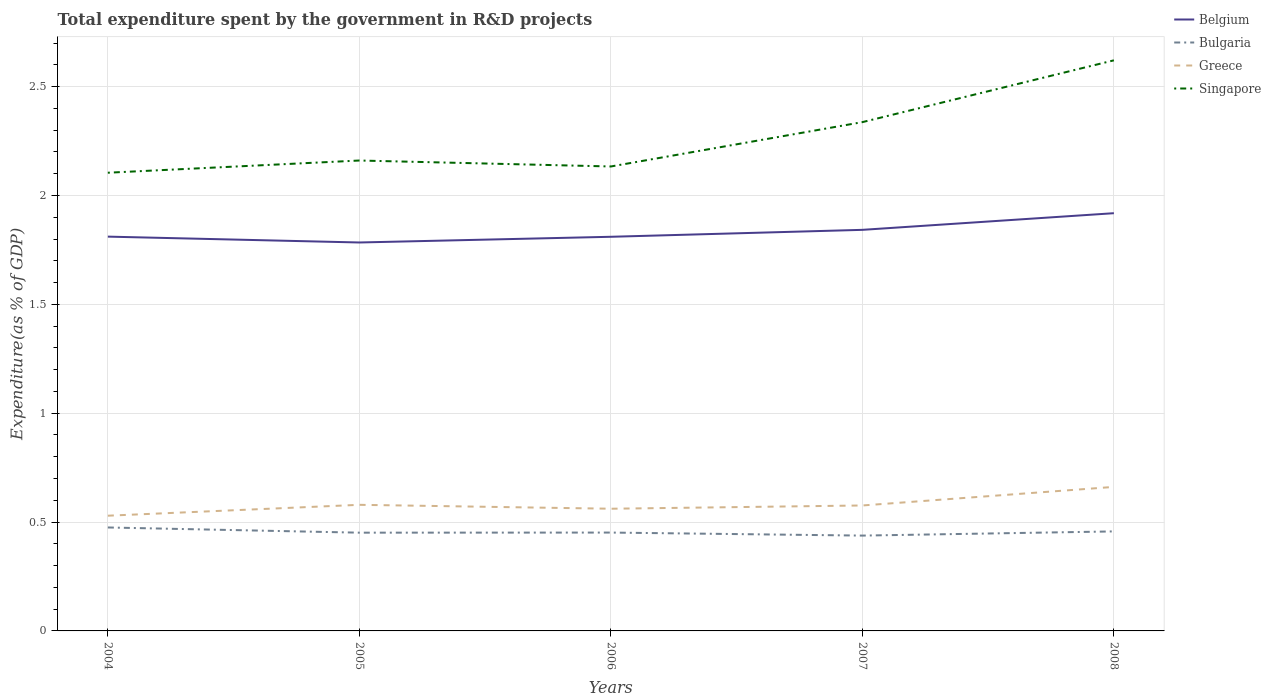Across all years, what is the maximum total expenditure spent by the government in R&D projects in Belgium?
Your answer should be compact. 1.78. What is the total total expenditure spent by the government in R&D projects in Greece in the graph?
Provide a succinct answer. 0. What is the difference between the highest and the second highest total expenditure spent by the government in R&D projects in Greece?
Your answer should be compact. 0.13. What is the difference between the highest and the lowest total expenditure spent by the government in R&D projects in Bulgaria?
Provide a succinct answer. 2. How many years are there in the graph?
Provide a short and direct response. 5. Are the values on the major ticks of Y-axis written in scientific E-notation?
Your answer should be compact. No. How many legend labels are there?
Keep it short and to the point. 4. What is the title of the graph?
Make the answer very short. Total expenditure spent by the government in R&D projects. Does "Romania" appear as one of the legend labels in the graph?
Make the answer very short. No. What is the label or title of the Y-axis?
Make the answer very short. Expenditure(as % of GDP). What is the Expenditure(as % of GDP) of Belgium in 2004?
Provide a succinct answer. 1.81. What is the Expenditure(as % of GDP) in Bulgaria in 2004?
Make the answer very short. 0.48. What is the Expenditure(as % of GDP) in Greece in 2004?
Give a very brief answer. 0.53. What is the Expenditure(as % of GDP) of Singapore in 2004?
Your answer should be compact. 2.1. What is the Expenditure(as % of GDP) in Belgium in 2005?
Keep it short and to the point. 1.78. What is the Expenditure(as % of GDP) in Bulgaria in 2005?
Provide a succinct answer. 0.45. What is the Expenditure(as % of GDP) of Greece in 2005?
Give a very brief answer. 0.58. What is the Expenditure(as % of GDP) in Singapore in 2005?
Keep it short and to the point. 2.16. What is the Expenditure(as % of GDP) in Belgium in 2006?
Keep it short and to the point. 1.81. What is the Expenditure(as % of GDP) of Bulgaria in 2006?
Provide a succinct answer. 0.45. What is the Expenditure(as % of GDP) in Greece in 2006?
Ensure brevity in your answer.  0.56. What is the Expenditure(as % of GDP) of Singapore in 2006?
Make the answer very short. 2.13. What is the Expenditure(as % of GDP) of Belgium in 2007?
Ensure brevity in your answer.  1.84. What is the Expenditure(as % of GDP) of Bulgaria in 2007?
Provide a short and direct response. 0.44. What is the Expenditure(as % of GDP) in Greece in 2007?
Your answer should be compact. 0.58. What is the Expenditure(as % of GDP) of Singapore in 2007?
Your answer should be compact. 2.34. What is the Expenditure(as % of GDP) in Belgium in 2008?
Your response must be concise. 1.92. What is the Expenditure(as % of GDP) of Bulgaria in 2008?
Offer a terse response. 0.46. What is the Expenditure(as % of GDP) in Greece in 2008?
Your answer should be compact. 0.66. What is the Expenditure(as % of GDP) in Singapore in 2008?
Offer a terse response. 2.62. Across all years, what is the maximum Expenditure(as % of GDP) of Belgium?
Give a very brief answer. 1.92. Across all years, what is the maximum Expenditure(as % of GDP) of Bulgaria?
Offer a very short reply. 0.48. Across all years, what is the maximum Expenditure(as % of GDP) of Greece?
Give a very brief answer. 0.66. Across all years, what is the maximum Expenditure(as % of GDP) of Singapore?
Your answer should be compact. 2.62. Across all years, what is the minimum Expenditure(as % of GDP) in Belgium?
Your answer should be compact. 1.78. Across all years, what is the minimum Expenditure(as % of GDP) in Bulgaria?
Give a very brief answer. 0.44. Across all years, what is the minimum Expenditure(as % of GDP) of Greece?
Offer a very short reply. 0.53. Across all years, what is the minimum Expenditure(as % of GDP) of Singapore?
Keep it short and to the point. 2.1. What is the total Expenditure(as % of GDP) in Belgium in the graph?
Your answer should be very brief. 9.17. What is the total Expenditure(as % of GDP) of Bulgaria in the graph?
Your answer should be compact. 2.27. What is the total Expenditure(as % of GDP) of Greece in the graph?
Offer a very short reply. 2.91. What is the total Expenditure(as % of GDP) in Singapore in the graph?
Provide a succinct answer. 11.36. What is the difference between the Expenditure(as % of GDP) of Belgium in 2004 and that in 2005?
Your answer should be very brief. 0.03. What is the difference between the Expenditure(as % of GDP) in Bulgaria in 2004 and that in 2005?
Your response must be concise. 0.02. What is the difference between the Expenditure(as % of GDP) of Greece in 2004 and that in 2005?
Give a very brief answer. -0.05. What is the difference between the Expenditure(as % of GDP) in Singapore in 2004 and that in 2005?
Keep it short and to the point. -0.06. What is the difference between the Expenditure(as % of GDP) in Belgium in 2004 and that in 2006?
Make the answer very short. 0. What is the difference between the Expenditure(as % of GDP) in Bulgaria in 2004 and that in 2006?
Your answer should be very brief. 0.02. What is the difference between the Expenditure(as % of GDP) of Greece in 2004 and that in 2006?
Ensure brevity in your answer.  -0.03. What is the difference between the Expenditure(as % of GDP) of Singapore in 2004 and that in 2006?
Make the answer very short. -0.03. What is the difference between the Expenditure(as % of GDP) in Belgium in 2004 and that in 2007?
Keep it short and to the point. -0.03. What is the difference between the Expenditure(as % of GDP) in Bulgaria in 2004 and that in 2007?
Provide a succinct answer. 0.04. What is the difference between the Expenditure(as % of GDP) of Greece in 2004 and that in 2007?
Your response must be concise. -0.05. What is the difference between the Expenditure(as % of GDP) in Singapore in 2004 and that in 2007?
Provide a succinct answer. -0.23. What is the difference between the Expenditure(as % of GDP) in Belgium in 2004 and that in 2008?
Make the answer very short. -0.11. What is the difference between the Expenditure(as % of GDP) of Bulgaria in 2004 and that in 2008?
Give a very brief answer. 0.02. What is the difference between the Expenditure(as % of GDP) in Greece in 2004 and that in 2008?
Your answer should be very brief. -0.13. What is the difference between the Expenditure(as % of GDP) of Singapore in 2004 and that in 2008?
Keep it short and to the point. -0.52. What is the difference between the Expenditure(as % of GDP) of Belgium in 2005 and that in 2006?
Make the answer very short. -0.03. What is the difference between the Expenditure(as % of GDP) in Bulgaria in 2005 and that in 2006?
Make the answer very short. -0. What is the difference between the Expenditure(as % of GDP) of Greece in 2005 and that in 2006?
Your answer should be very brief. 0.02. What is the difference between the Expenditure(as % of GDP) in Singapore in 2005 and that in 2006?
Give a very brief answer. 0.03. What is the difference between the Expenditure(as % of GDP) of Belgium in 2005 and that in 2007?
Your answer should be compact. -0.06. What is the difference between the Expenditure(as % of GDP) in Bulgaria in 2005 and that in 2007?
Your answer should be very brief. 0.01. What is the difference between the Expenditure(as % of GDP) of Greece in 2005 and that in 2007?
Offer a very short reply. 0. What is the difference between the Expenditure(as % of GDP) in Singapore in 2005 and that in 2007?
Your answer should be very brief. -0.18. What is the difference between the Expenditure(as % of GDP) in Belgium in 2005 and that in 2008?
Provide a succinct answer. -0.13. What is the difference between the Expenditure(as % of GDP) in Bulgaria in 2005 and that in 2008?
Offer a terse response. -0.01. What is the difference between the Expenditure(as % of GDP) of Greece in 2005 and that in 2008?
Provide a short and direct response. -0.08. What is the difference between the Expenditure(as % of GDP) in Singapore in 2005 and that in 2008?
Offer a terse response. -0.46. What is the difference between the Expenditure(as % of GDP) in Belgium in 2006 and that in 2007?
Your answer should be very brief. -0.03. What is the difference between the Expenditure(as % of GDP) in Bulgaria in 2006 and that in 2007?
Offer a very short reply. 0.01. What is the difference between the Expenditure(as % of GDP) of Greece in 2006 and that in 2007?
Keep it short and to the point. -0.01. What is the difference between the Expenditure(as % of GDP) in Singapore in 2006 and that in 2007?
Keep it short and to the point. -0.2. What is the difference between the Expenditure(as % of GDP) of Belgium in 2006 and that in 2008?
Keep it short and to the point. -0.11. What is the difference between the Expenditure(as % of GDP) of Bulgaria in 2006 and that in 2008?
Your answer should be compact. -0.01. What is the difference between the Expenditure(as % of GDP) in Greece in 2006 and that in 2008?
Provide a short and direct response. -0.1. What is the difference between the Expenditure(as % of GDP) in Singapore in 2006 and that in 2008?
Offer a terse response. -0.49. What is the difference between the Expenditure(as % of GDP) of Belgium in 2007 and that in 2008?
Your response must be concise. -0.08. What is the difference between the Expenditure(as % of GDP) of Bulgaria in 2007 and that in 2008?
Provide a short and direct response. -0.02. What is the difference between the Expenditure(as % of GDP) in Greece in 2007 and that in 2008?
Make the answer very short. -0.09. What is the difference between the Expenditure(as % of GDP) of Singapore in 2007 and that in 2008?
Your answer should be very brief. -0.28. What is the difference between the Expenditure(as % of GDP) of Belgium in 2004 and the Expenditure(as % of GDP) of Bulgaria in 2005?
Give a very brief answer. 1.36. What is the difference between the Expenditure(as % of GDP) of Belgium in 2004 and the Expenditure(as % of GDP) of Greece in 2005?
Make the answer very short. 1.23. What is the difference between the Expenditure(as % of GDP) of Belgium in 2004 and the Expenditure(as % of GDP) of Singapore in 2005?
Your answer should be compact. -0.35. What is the difference between the Expenditure(as % of GDP) in Bulgaria in 2004 and the Expenditure(as % of GDP) in Greece in 2005?
Offer a very short reply. -0.1. What is the difference between the Expenditure(as % of GDP) in Bulgaria in 2004 and the Expenditure(as % of GDP) in Singapore in 2005?
Your answer should be very brief. -1.69. What is the difference between the Expenditure(as % of GDP) in Greece in 2004 and the Expenditure(as % of GDP) in Singapore in 2005?
Ensure brevity in your answer.  -1.63. What is the difference between the Expenditure(as % of GDP) in Belgium in 2004 and the Expenditure(as % of GDP) in Bulgaria in 2006?
Your response must be concise. 1.36. What is the difference between the Expenditure(as % of GDP) in Belgium in 2004 and the Expenditure(as % of GDP) in Greece in 2006?
Your answer should be very brief. 1.25. What is the difference between the Expenditure(as % of GDP) in Belgium in 2004 and the Expenditure(as % of GDP) in Singapore in 2006?
Make the answer very short. -0.32. What is the difference between the Expenditure(as % of GDP) in Bulgaria in 2004 and the Expenditure(as % of GDP) in Greece in 2006?
Provide a succinct answer. -0.09. What is the difference between the Expenditure(as % of GDP) of Bulgaria in 2004 and the Expenditure(as % of GDP) of Singapore in 2006?
Offer a very short reply. -1.66. What is the difference between the Expenditure(as % of GDP) in Greece in 2004 and the Expenditure(as % of GDP) in Singapore in 2006?
Ensure brevity in your answer.  -1.6. What is the difference between the Expenditure(as % of GDP) in Belgium in 2004 and the Expenditure(as % of GDP) in Bulgaria in 2007?
Offer a terse response. 1.37. What is the difference between the Expenditure(as % of GDP) of Belgium in 2004 and the Expenditure(as % of GDP) of Greece in 2007?
Give a very brief answer. 1.23. What is the difference between the Expenditure(as % of GDP) in Belgium in 2004 and the Expenditure(as % of GDP) in Singapore in 2007?
Keep it short and to the point. -0.53. What is the difference between the Expenditure(as % of GDP) in Bulgaria in 2004 and the Expenditure(as % of GDP) in Greece in 2007?
Offer a very short reply. -0.1. What is the difference between the Expenditure(as % of GDP) in Bulgaria in 2004 and the Expenditure(as % of GDP) in Singapore in 2007?
Offer a terse response. -1.86. What is the difference between the Expenditure(as % of GDP) in Greece in 2004 and the Expenditure(as % of GDP) in Singapore in 2007?
Offer a terse response. -1.81. What is the difference between the Expenditure(as % of GDP) in Belgium in 2004 and the Expenditure(as % of GDP) in Bulgaria in 2008?
Offer a very short reply. 1.35. What is the difference between the Expenditure(as % of GDP) in Belgium in 2004 and the Expenditure(as % of GDP) in Greece in 2008?
Provide a short and direct response. 1.15. What is the difference between the Expenditure(as % of GDP) in Belgium in 2004 and the Expenditure(as % of GDP) in Singapore in 2008?
Provide a short and direct response. -0.81. What is the difference between the Expenditure(as % of GDP) in Bulgaria in 2004 and the Expenditure(as % of GDP) in Greece in 2008?
Offer a terse response. -0.19. What is the difference between the Expenditure(as % of GDP) in Bulgaria in 2004 and the Expenditure(as % of GDP) in Singapore in 2008?
Your answer should be very brief. -2.15. What is the difference between the Expenditure(as % of GDP) in Greece in 2004 and the Expenditure(as % of GDP) in Singapore in 2008?
Your answer should be compact. -2.09. What is the difference between the Expenditure(as % of GDP) of Belgium in 2005 and the Expenditure(as % of GDP) of Bulgaria in 2006?
Give a very brief answer. 1.33. What is the difference between the Expenditure(as % of GDP) of Belgium in 2005 and the Expenditure(as % of GDP) of Greece in 2006?
Your answer should be very brief. 1.22. What is the difference between the Expenditure(as % of GDP) in Belgium in 2005 and the Expenditure(as % of GDP) in Singapore in 2006?
Keep it short and to the point. -0.35. What is the difference between the Expenditure(as % of GDP) in Bulgaria in 2005 and the Expenditure(as % of GDP) in Greece in 2006?
Provide a short and direct response. -0.11. What is the difference between the Expenditure(as % of GDP) of Bulgaria in 2005 and the Expenditure(as % of GDP) of Singapore in 2006?
Your answer should be compact. -1.68. What is the difference between the Expenditure(as % of GDP) of Greece in 2005 and the Expenditure(as % of GDP) of Singapore in 2006?
Your answer should be very brief. -1.55. What is the difference between the Expenditure(as % of GDP) in Belgium in 2005 and the Expenditure(as % of GDP) in Bulgaria in 2007?
Offer a terse response. 1.35. What is the difference between the Expenditure(as % of GDP) in Belgium in 2005 and the Expenditure(as % of GDP) in Greece in 2007?
Offer a terse response. 1.21. What is the difference between the Expenditure(as % of GDP) in Belgium in 2005 and the Expenditure(as % of GDP) in Singapore in 2007?
Ensure brevity in your answer.  -0.55. What is the difference between the Expenditure(as % of GDP) in Bulgaria in 2005 and the Expenditure(as % of GDP) in Greece in 2007?
Your answer should be compact. -0.12. What is the difference between the Expenditure(as % of GDP) of Bulgaria in 2005 and the Expenditure(as % of GDP) of Singapore in 2007?
Keep it short and to the point. -1.89. What is the difference between the Expenditure(as % of GDP) in Greece in 2005 and the Expenditure(as % of GDP) in Singapore in 2007?
Make the answer very short. -1.76. What is the difference between the Expenditure(as % of GDP) of Belgium in 2005 and the Expenditure(as % of GDP) of Bulgaria in 2008?
Your answer should be compact. 1.33. What is the difference between the Expenditure(as % of GDP) of Belgium in 2005 and the Expenditure(as % of GDP) of Greece in 2008?
Your answer should be very brief. 1.12. What is the difference between the Expenditure(as % of GDP) in Belgium in 2005 and the Expenditure(as % of GDP) in Singapore in 2008?
Offer a terse response. -0.84. What is the difference between the Expenditure(as % of GDP) in Bulgaria in 2005 and the Expenditure(as % of GDP) in Greece in 2008?
Make the answer very short. -0.21. What is the difference between the Expenditure(as % of GDP) in Bulgaria in 2005 and the Expenditure(as % of GDP) in Singapore in 2008?
Your answer should be very brief. -2.17. What is the difference between the Expenditure(as % of GDP) in Greece in 2005 and the Expenditure(as % of GDP) in Singapore in 2008?
Ensure brevity in your answer.  -2.04. What is the difference between the Expenditure(as % of GDP) in Belgium in 2006 and the Expenditure(as % of GDP) in Bulgaria in 2007?
Make the answer very short. 1.37. What is the difference between the Expenditure(as % of GDP) in Belgium in 2006 and the Expenditure(as % of GDP) in Greece in 2007?
Provide a succinct answer. 1.23. What is the difference between the Expenditure(as % of GDP) in Belgium in 2006 and the Expenditure(as % of GDP) in Singapore in 2007?
Your response must be concise. -0.53. What is the difference between the Expenditure(as % of GDP) in Bulgaria in 2006 and the Expenditure(as % of GDP) in Greece in 2007?
Your answer should be very brief. -0.12. What is the difference between the Expenditure(as % of GDP) of Bulgaria in 2006 and the Expenditure(as % of GDP) of Singapore in 2007?
Offer a very short reply. -1.89. What is the difference between the Expenditure(as % of GDP) of Greece in 2006 and the Expenditure(as % of GDP) of Singapore in 2007?
Your answer should be very brief. -1.78. What is the difference between the Expenditure(as % of GDP) in Belgium in 2006 and the Expenditure(as % of GDP) in Bulgaria in 2008?
Your response must be concise. 1.35. What is the difference between the Expenditure(as % of GDP) in Belgium in 2006 and the Expenditure(as % of GDP) in Greece in 2008?
Offer a very short reply. 1.15. What is the difference between the Expenditure(as % of GDP) in Belgium in 2006 and the Expenditure(as % of GDP) in Singapore in 2008?
Offer a very short reply. -0.81. What is the difference between the Expenditure(as % of GDP) in Bulgaria in 2006 and the Expenditure(as % of GDP) in Greece in 2008?
Offer a very short reply. -0.21. What is the difference between the Expenditure(as % of GDP) in Bulgaria in 2006 and the Expenditure(as % of GDP) in Singapore in 2008?
Provide a short and direct response. -2.17. What is the difference between the Expenditure(as % of GDP) of Greece in 2006 and the Expenditure(as % of GDP) of Singapore in 2008?
Offer a very short reply. -2.06. What is the difference between the Expenditure(as % of GDP) in Belgium in 2007 and the Expenditure(as % of GDP) in Bulgaria in 2008?
Keep it short and to the point. 1.39. What is the difference between the Expenditure(as % of GDP) of Belgium in 2007 and the Expenditure(as % of GDP) of Greece in 2008?
Make the answer very short. 1.18. What is the difference between the Expenditure(as % of GDP) of Belgium in 2007 and the Expenditure(as % of GDP) of Singapore in 2008?
Give a very brief answer. -0.78. What is the difference between the Expenditure(as % of GDP) in Bulgaria in 2007 and the Expenditure(as % of GDP) in Greece in 2008?
Provide a succinct answer. -0.22. What is the difference between the Expenditure(as % of GDP) in Bulgaria in 2007 and the Expenditure(as % of GDP) in Singapore in 2008?
Provide a short and direct response. -2.18. What is the difference between the Expenditure(as % of GDP) of Greece in 2007 and the Expenditure(as % of GDP) of Singapore in 2008?
Offer a very short reply. -2.04. What is the average Expenditure(as % of GDP) of Belgium per year?
Your response must be concise. 1.83. What is the average Expenditure(as % of GDP) in Bulgaria per year?
Provide a short and direct response. 0.45. What is the average Expenditure(as % of GDP) of Greece per year?
Make the answer very short. 0.58. What is the average Expenditure(as % of GDP) of Singapore per year?
Your answer should be compact. 2.27. In the year 2004, what is the difference between the Expenditure(as % of GDP) in Belgium and Expenditure(as % of GDP) in Bulgaria?
Your answer should be very brief. 1.34. In the year 2004, what is the difference between the Expenditure(as % of GDP) in Belgium and Expenditure(as % of GDP) in Greece?
Ensure brevity in your answer.  1.28. In the year 2004, what is the difference between the Expenditure(as % of GDP) of Belgium and Expenditure(as % of GDP) of Singapore?
Offer a very short reply. -0.29. In the year 2004, what is the difference between the Expenditure(as % of GDP) in Bulgaria and Expenditure(as % of GDP) in Greece?
Provide a succinct answer. -0.05. In the year 2004, what is the difference between the Expenditure(as % of GDP) of Bulgaria and Expenditure(as % of GDP) of Singapore?
Keep it short and to the point. -1.63. In the year 2004, what is the difference between the Expenditure(as % of GDP) of Greece and Expenditure(as % of GDP) of Singapore?
Keep it short and to the point. -1.58. In the year 2005, what is the difference between the Expenditure(as % of GDP) of Belgium and Expenditure(as % of GDP) of Bulgaria?
Provide a short and direct response. 1.33. In the year 2005, what is the difference between the Expenditure(as % of GDP) of Belgium and Expenditure(as % of GDP) of Greece?
Offer a very short reply. 1.21. In the year 2005, what is the difference between the Expenditure(as % of GDP) in Belgium and Expenditure(as % of GDP) in Singapore?
Provide a short and direct response. -0.38. In the year 2005, what is the difference between the Expenditure(as % of GDP) in Bulgaria and Expenditure(as % of GDP) in Greece?
Your answer should be compact. -0.13. In the year 2005, what is the difference between the Expenditure(as % of GDP) in Bulgaria and Expenditure(as % of GDP) in Singapore?
Your response must be concise. -1.71. In the year 2005, what is the difference between the Expenditure(as % of GDP) in Greece and Expenditure(as % of GDP) in Singapore?
Provide a short and direct response. -1.58. In the year 2006, what is the difference between the Expenditure(as % of GDP) in Belgium and Expenditure(as % of GDP) in Bulgaria?
Keep it short and to the point. 1.36. In the year 2006, what is the difference between the Expenditure(as % of GDP) in Belgium and Expenditure(as % of GDP) in Greece?
Give a very brief answer. 1.25. In the year 2006, what is the difference between the Expenditure(as % of GDP) of Belgium and Expenditure(as % of GDP) of Singapore?
Your answer should be very brief. -0.32. In the year 2006, what is the difference between the Expenditure(as % of GDP) of Bulgaria and Expenditure(as % of GDP) of Greece?
Provide a succinct answer. -0.11. In the year 2006, what is the difference between the Expenditure(as % of GDP) in Bulgaria and Expenditure(as % of GDP) in Singapore?
Your response must be concise. -1.68. In the year 2006, what is the difference between the Expenditure(as % of GDP) of Greece and Expenditure(as % of GDP) of Singapore?
Your answer should be very brief. -1.57. In the year 2007, what is the difference between the Expenditure(as % of GDP) in Belgium and Expenditure(as % of GDP) in Bulgaria?
Offer a very short reply. 1.4. In the year 2007, what is the difference between the Expenditure(as % of GDP) in Belgium and Expenditure(as % of GDP) in Greece?
Your response must be concise. 1.27. In the year 2007, what is the difference between the Expenditure(as % of GDP) of Belgium and Expenditure(as % of GDP) of Singapore?
Your answer should be compact. -0.49. In the year 2007, what is the difference between the Expenditure(as % of GDP) in Bulgaria and Expenditure(as % of GDP) in Greece?
Offer a very short reply. -0.14. In the year 2007, what is the difference between the Expenditure(as % of GDP) in Bulgaria and Expenditure(as % of GDP) in Singapore?
Provide a short and direct response. -1.9. In the year 2007, what is the difference between the Expenditure(as % of GDP) in Greece and Expenditure(as % of GDP) in Singapore?
Provide a succinct answer. -1.76. In the year 2008, what is the difference between the Expenditure(as % of GDP) in Belgium and Expenditure(as % of GDP) in Bulgaria?
Offer a very short reply. 1.46. In the year 2008, what is the difference between the Expenditure(as % of GDP) of Belgium and Expenditure(as % of GDP) of Greece?
Offer a very short reply. 1.26. In the year 2008, what is the difference between the Expenditure(as % of GDP) in Belgium and Expenditure(as % of GDP) in Singapore?
Give a very brief answer. -0.7. In the year 2008, what is the difference between the Expenditure(as % of GDP) in Bulgaria and Expenditure(as % of GDP) in Greece?
Provide a succinct answer. -0.2. In the year 2008, what is the difference between the Expenditure(as % of GDP) of Bulgaria and Expenditure(as % of GDP) of Singapore?
Offer a very short reply. -2.16. In the year 2008, what is the difference between the Expenditure(as % of GDP) of Greece and Expenditure(as % of GDP) of Singapore?
Your response must be concise. -1.96. What is the ratio of the Expenditure(as % of GDP) of Belgium in 2004 to that in 2005?
Your answer should be compact. 1.02. What is the ratio of the Expenditure(as % of GDP) of Bulgaria in 2004 to that in 2005?
Make the answer very short. 1.05. What is the ratio of the Expenditure(as % of GDP) of Greece in 2004 to that in 2005?
Provide a succinct answer. 0.91. What is the ratio of the Expenditure(as % of GDP) in Singapore in 2004 to that in 2005?
Your answer should be very brief. 0.97. What is the ratio of the Expenditure(as % of GDP) in Belgium in 2004 to that in 2006?
Your answer should be very brief. 1. What is the ratio of the Expenditure(as % of GDP) in Bulgaria in 2004 to that in 2006?
Keep it short and to the point. 1.05. What is the ratio of the Expenditure(as % of GDP) of Greece in 2004 to that in 2006?
Offer a terse response. 0.94. What is the ratio of the Expenditure(as % of GDP) of Singapore in 2004 to that in 2006?
Your answer should be very brief. 0.99. What is the ratio of the Expenditure(as % of GDP) of Belgium in 2004 to that in 2007?
Provide a short and direct response. 0.98. What is the ratio of the Expenditure(as % of GDP) in Bulgaria in 2004 to that in 2007?
Offer a very short reply. 1.09. What is the ratio of the Expenditure(as % of GDP) in Greece in 2004 to that in 2007?
Give a very brief answer. 0.92. What is the ratio of the Expenditure(as % of GDP) of Singapore in 2004 to that in 2007?
Provide a succinct answer. 0.9. What is the ratio of the Expenditure(as % of GDP) in Belgium in 2004 to that in 2008?
Your response must be concise. 0.94. What is the ratio of the Expenditure(as % of GDP) of Bulgaria in 2004 to that in 2008?
Keep it short and to the point. 1.04. What is the ratio of the Expenditure(as % of GDP) of Singapore in 2004 to that in 2008?
Make the answer very short. 0.8. What is the ratio of the Expenditure(as % of GDP) in Belgium in 2005 to that in 2006?
Your answer should be very brief. 0.99. What is the ratio of the Expenditure(as % of GDP) of Greece in 2005 to that in 2006?
Keep it short and to the point. 1.03. What is the ratio of the Expenditure(as % of GDP) of Singapore in 2005 to that in 2006?
Make the answer very short. 1.01. What is the ratio of the Expenditure(as % of GDP) in Belgium in 2005 to that in 2007?
Your response must be concise. 0.97. What is the ratio of the Expenditure(as % of GDP) of Bulgaria in 2005 to that in 2007?
Offer a very short reply. 1.03. What is the ratio of the Expenditure(as % of GDP) of Greece in 2005 to that in 2007?
Give a very brief answer. 1.01. What is the ratio of the Expenditure(as % of GDP) in Singapore in 2005 to that in 2007?
Offer a very short reply. 0.92. What is the ratio of the Expenditure(as % of GDP) in Belgium in 2005 to that in 2008?
Your answer should be very brief. 0.93. What is the ratio of the Expenditure(as % of GDP) in Bulgaria in 2005 to that in 2008?
Your response must be concise. 0.99. What is the ratio of the Expenditure(as % of GDP) in Greece in 2005 to that in 2008?
Provide a short and direct response. 0.88. What is the ratio of the Expenditure(as % of GDP) of Singapore in 2005 to that in 2008?
Your answer should be compact. 0.82. What is the ratio of the Expenditure(as % of GDP) of Belgium in 2006 to that in 2007?
Your answer should be compact. 0.98. What is the ratio of the Expenditure(as % of GDP) in Bulgaria in 2006 to that in 2007?
Offer a terse response. 1.03. What is the ratio of the Expenditure(as % of GDP) in Greece in 2006 to that in 2007?
Provide a short and direct response. 0.97. What is the ratio of the Expenditure(as % of GDP) in Singapore in 2006 to that in 2007?
Provide a short and direct response. 0.91. What is the ratio of the Expenditure(as % of GDP) of Belgium in 2006 to that in 2008?
Your response must be concise. 0.94. What is the ratio of the Expenditure(as % of GDP) of Bulgaria in 2006 to that in 2008?
Ensure brevity in your answer.  0.99. What is the ratio of the Expenditure(as % of GDP) of Greece in 2006 to that in 2008?
Ensure brevity in your answer.  0.85. What is the ratio of the Expenditure(as % of GDP) of Singapore in 2006 to that in 2008?
Keep it short and to the point. 0.81. What is the ratio of the Expenditure(as % of GDP) in Belgium in 2007 to that in 2008?
Your answer should be compact. 0.96. What is the ratio of the Expenditure(as % of GDP) of Bulgaria in 2007 to that in 2008?
Your answer should be very brief. 0.96. What is the ratio of the Expenditure(as % of GDP) of Greece in 2007 to that in 2008?
Your response must be concise. 0.87. What is the ratio of the Expenditure(as % of GDP) in Singapore in 2007 to that in 2008?
Offer a terse response. 0.89. What is the difference between the highest and the second highest Expenditure(as % of GDP) in Belgium?
Ensure brevity in your answer.  0.08. What is the difference between the highest and the second highest Expenditure(as % of GDP) in Bulgaria?
Provide a succinct answer. 0.02. What is the difference between the highest and the second highest Expenditure(as % of GDP) of Greece?
Your answer should be very brief. 0.08. What is the difference between the highest and the second highest Expenditure(as % of GDP) in Singapore?
Your response must be concise. 0.28. What is the difference between the highest and the lowest Expenditure(as % of GDP) of Belgium?
Offer a terse response. 0.13. What is the difference between the highest and the lowest Expenditure(as % of GDP) in Bulgaria?
Provide a short and direct response. 0.04. What is the difference between the highest and the lowest Expenditure(as % of GDP) of Greece?
Keep it short and to the point. 0.13. What is the difference between the highest and the lowest Expenditure(as % of GDP) in Singapore?
Your response must be concise. 0.52. 